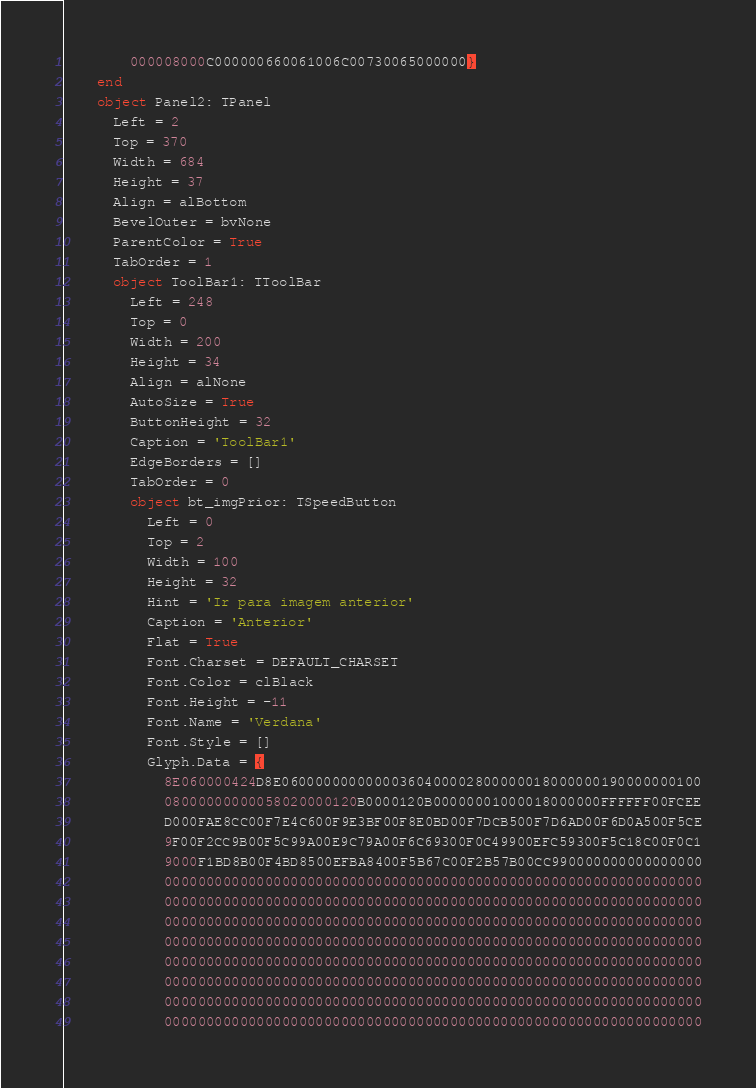<code> <loc_0><loc_0><loc_500><loc_500><_Pascal_>        000008000C000000660061006C00730065000000}
    end
    object Panel2: TPanel
      Left = 2
      Top = 370
      Width = 684
      Height = 37
      Align = alBottom
      BevelOuter = bvNone
      ParentColor = True
      TabOrder = 1
      object ToolBar1: TToolBar
        Left = 248
        Top = 0
        Width = 200
        Height = 34
        Align = alNone
        AutoSize = True
        ButtonHeight = 32
        Caption = 'ToolBar1'
        EdgeBorders = []
        TabOrder = 0
        object bt_imgPrior: TSpeedButton
          Left = 0
          Top = 2
          Width = 100
          Height = 32
          Hint = 'Ir para imagem anterior'
          Caption = 'Anterior'
          Flat = True
          Font.Charset = DEFAULT_CHARSET
          Font.Color = clBlack
          Font.Height = -11
          Font.Name = 'Verdana'
          Font.Style = []
          Glyph.Data = {
            8E060000424D8E06000000000000360400002800000018000000190000000100
            08000000000058020000120B0000120B00000001000018000000FFFFFF00FCEE
            D000FAE8CC00F7E4C600F9E3BF00F8E0BD00F7DCB500F7D6AD00F6D0A500F5CE
            9F00F2CC9B00F5C99A00E9C79A00F6C69300F0C49900EFC59300F5C18C00F0C1
            9000F1BD8B00F4BD8500EFBA8400F5B67C00F2B57B00CC990000000000000000
            0000000000000000000000000000000000000000000000000000000000000000
            0000000000000000000000000000000000000000000000000000000000000000
            0000000000000000000000000000000000000000000000000000000000000000
            0000000000000000000000000000000000000000000000000000000000000000
            0000000000000000000000000000000000000000000000000000000000000000
            0000000000000000000000000000000000000000000000000000000000000000
            0000000000000000000000000000000000000000000000000000000000000000
            0000000000000000000000000000000000000000000000000000000000000000</code> 